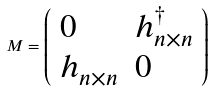<formula> <loc_0><loc_0><loc_500><loc_500>M = \left ( \begin{array} { l l } 0 & h ^ { \dagger } _ { n \times n } \\ h _ { n \times n } & 0 \end{array} \right )</formula> 